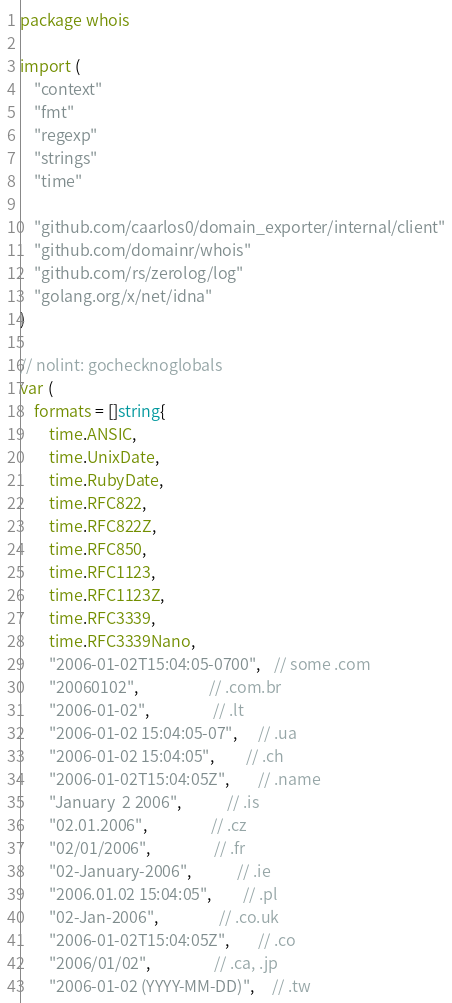<code> <loc_0><loc_0><loc_500><loc_500><_Go_>package whois

import (
	"context"
	"fmt"
	"regexp"
	"strings"
	"time"

	"github.com/caarlos0/domain_exporter/internal/client"
	"github.com/domainr/whois"
	"github.com/rs/zerolog/log"
	"golang.org/x/net/idna"
)

// nolint: gochecknoglobals
var (
	formats = []string{
		time.ANSIC,
		time.UnixDate,
		time.RubyDate,
		time.RFC822,
		time.RFC822Z,
		time.RFC850,
		time.RFC1123,
		time.RFC1123Z,
		time.RFC3339,
		time.RFC3339Nano,
		"2006-01-02T15:04:05-0700",    // some .com
		"20060102",                    // .com.br
		"2006-01-02",                  // .lt
		"2006-01-02 15:04:05-07",      // .ua
		"2006-01-02 15:04:05",         // .ch
		"2006-01-02T15:04:05Z",        // .name
		"January  2 2006",             // .is
		"02.01.2006",                  // .cz
		"02/01/2006",                  // .fr
		"02-January-2006",             // .ie
		"2006.01.02 15:04:05",         // .pl
		"02-Jan-2006",                 // .co.uk
		"2006-01-02T15:04:05Z",        // .co
		"2006/01/02",                  // .ca, .jp
		"2006-01-02 (YYYY-MM-DD)",     // .tw</code> 